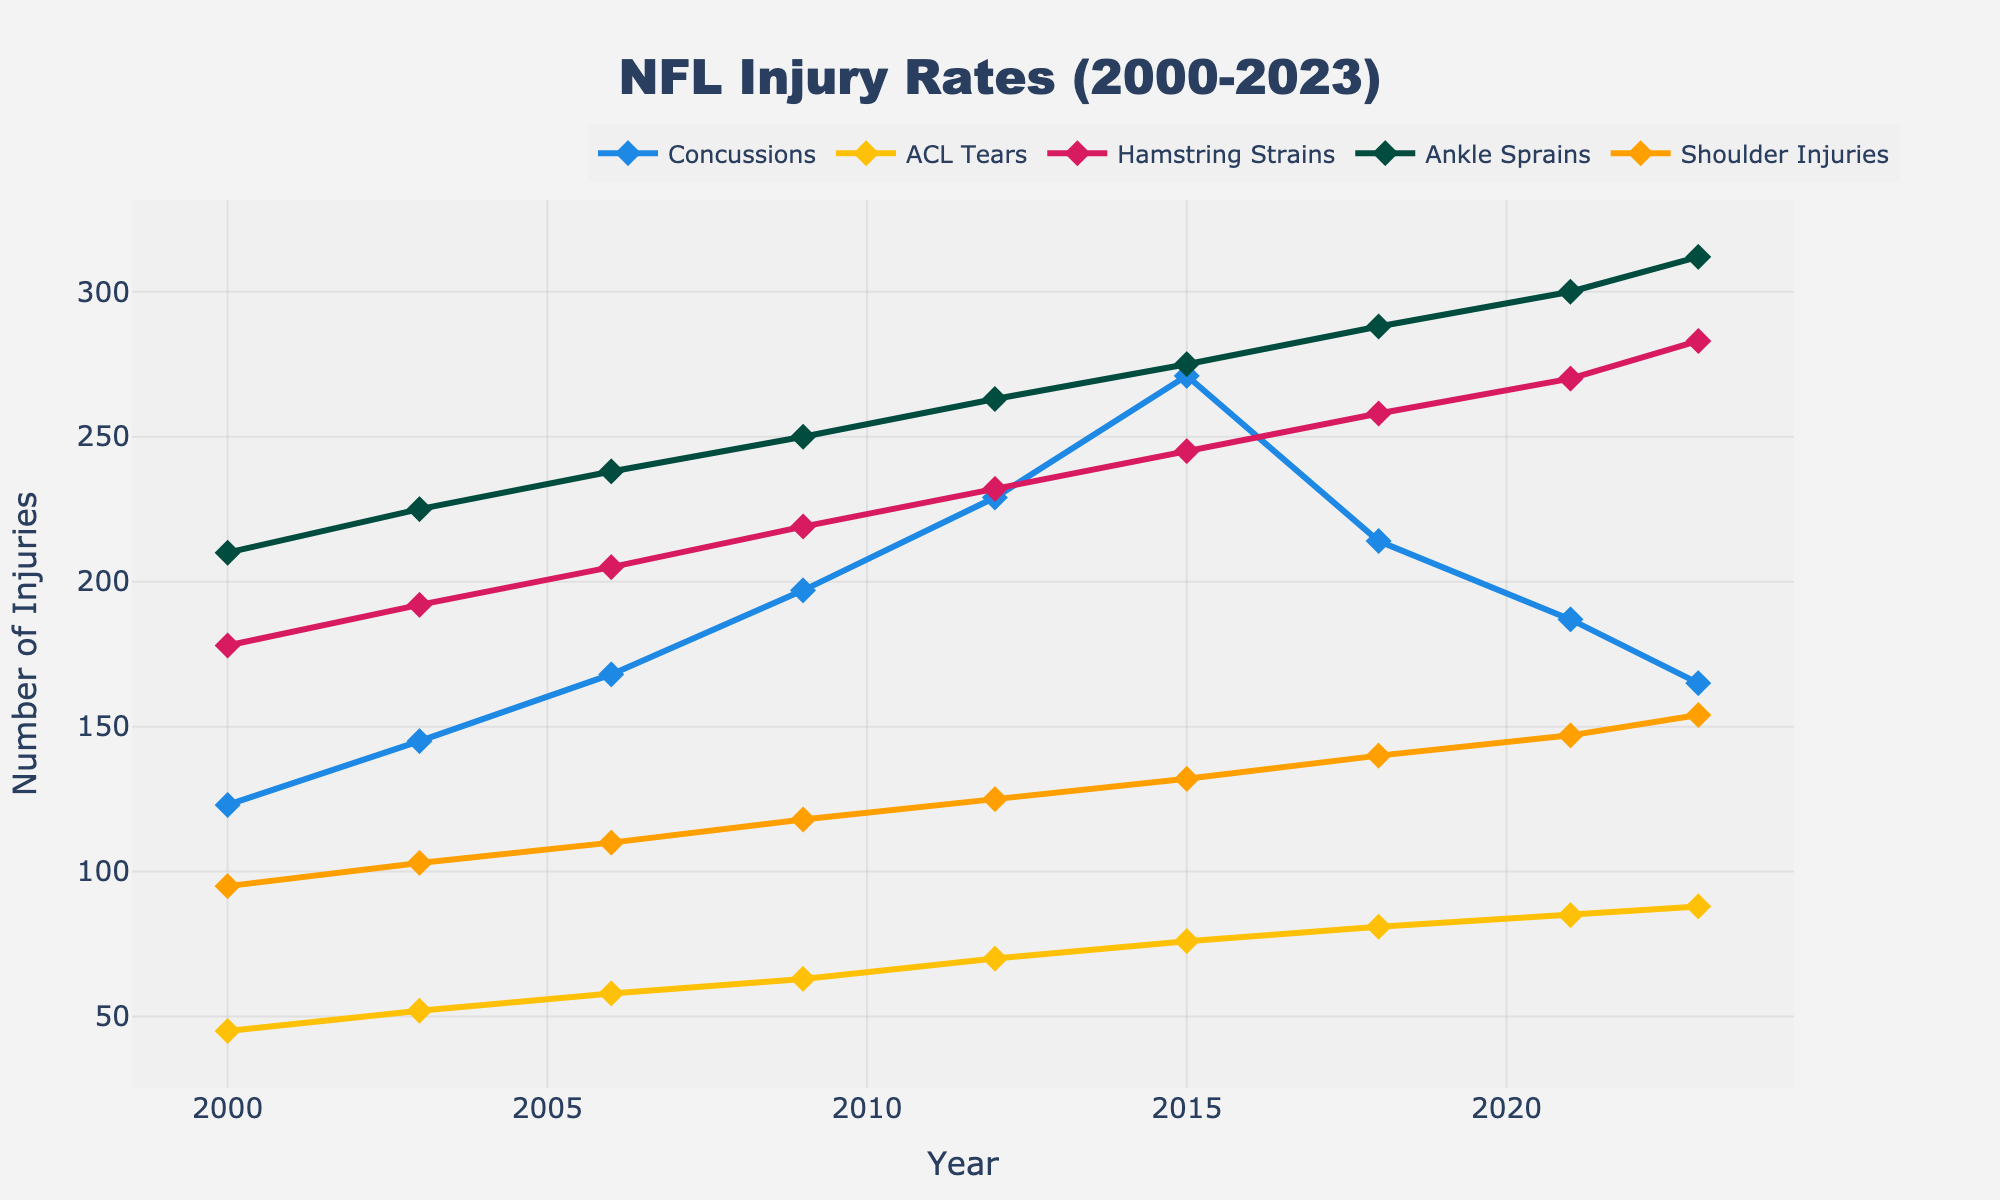Which type of injury had the highest rate in 2023? The data for 2023 shows the numbers for each injury type, and Ankle Sprains have the highest number at 312.
Answer: Ankle Sprains How did the rate of concussions change from 2015 to 2023? Comparing the concussions in 2015 (271) and 2023 (165), the rate decreased by 271 - 165, equaling 106.
Answer: Decreased by 106 What is the average number of ACL Tears from 2000 to 2023? Sum up the number of ACL Tears for each year and divide by the number of years. (45 + 52 + 58 + 63 + 70 + 76 + 81 + 85 + 88) / 9 equals 68.
Answer: 68 Which injury type saw the most significant rise from 2000 to 2023? Calculate the increase for each injury type. Concussions rose by 42, ACL Tears by 43, Hamstring Strains by 105, Ankle Sprains by 102, and Shoulder Injuries by 59. Hamstring Strains had the largest rise, increasing by 105.
Answer: Hamstring Strains In which year did Shoulder Injuries surpass 140? Looking at the data, Shoulder Injuries first surpassed 140 in 2018 when the value reached 140.
Answer: 2018 What is the combined number of Ankle Sprains and Hamstring Strains in 2021? Sum the data for Ankle Sprains (300) and Hamstring Strains (270) for the year 2021, which equals 570.
Answer: 570 Which injury type had the most stable rate over the years 2000 to 2023? By visually comparing the trends, ACL Tears show the least fluctuation and gradual increase compared to other injury types.
Answer: ACL Tears In which years did the rate of Concussions exceed 200? Refer to the data for concussions and note the years where the value is above 200. These years are 2009, 2012, and 2015.
Answer: 2009, 2012, 2015 What was the trend in the number of Hamstring Strains between 2006 and 2023? Observing the numbers from 2006 (205) to 2023 (283), the rate shows a general upward trend.
Answer: Upward Trend 